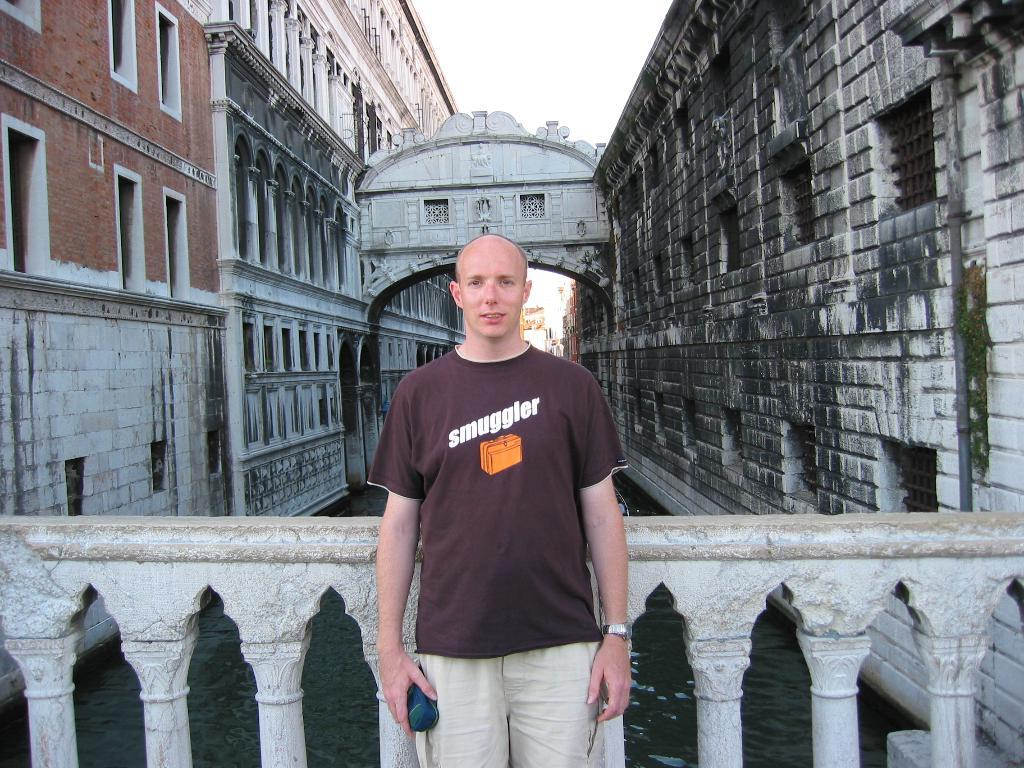Who is the main subject in the front of the image? There is a man standing in the front of the image. What can be seen on both sides of the image? There are buildings on both sides of the image. What is in the middle of the image? There is water in the middle of the image. What is visible in the background of the image? The sky is visible in the image. Where is the mother in the image? There is no mention of a mother in the image; it only features a man, buildings, water, and the sky. 